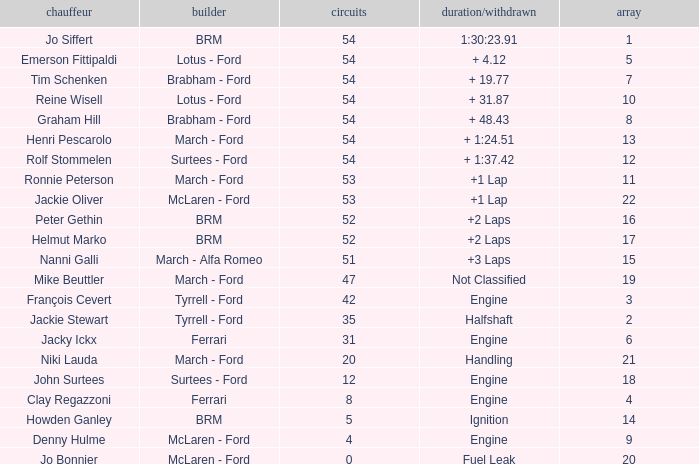What is the low grid that has brm and over 54 laps? None. 